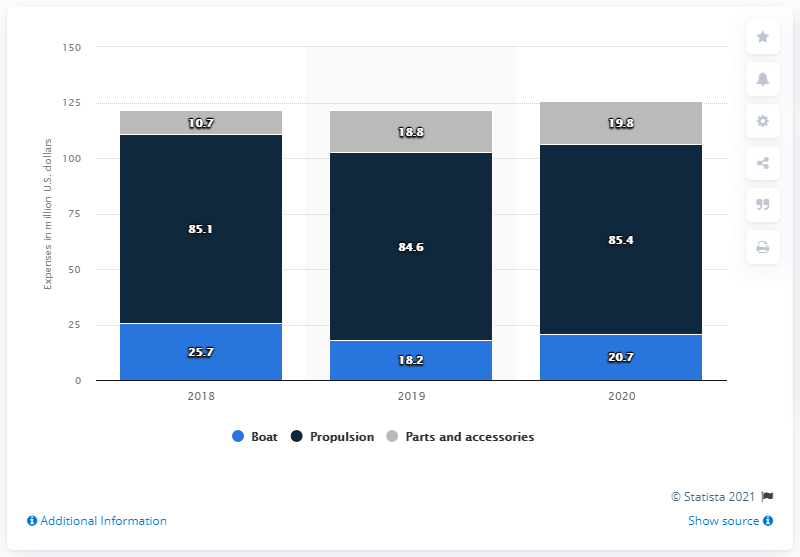List a handful of essential elements in this visual. In 2020, the Brunswick Corporation spent $20.7 million on research and development in the boat segment. 